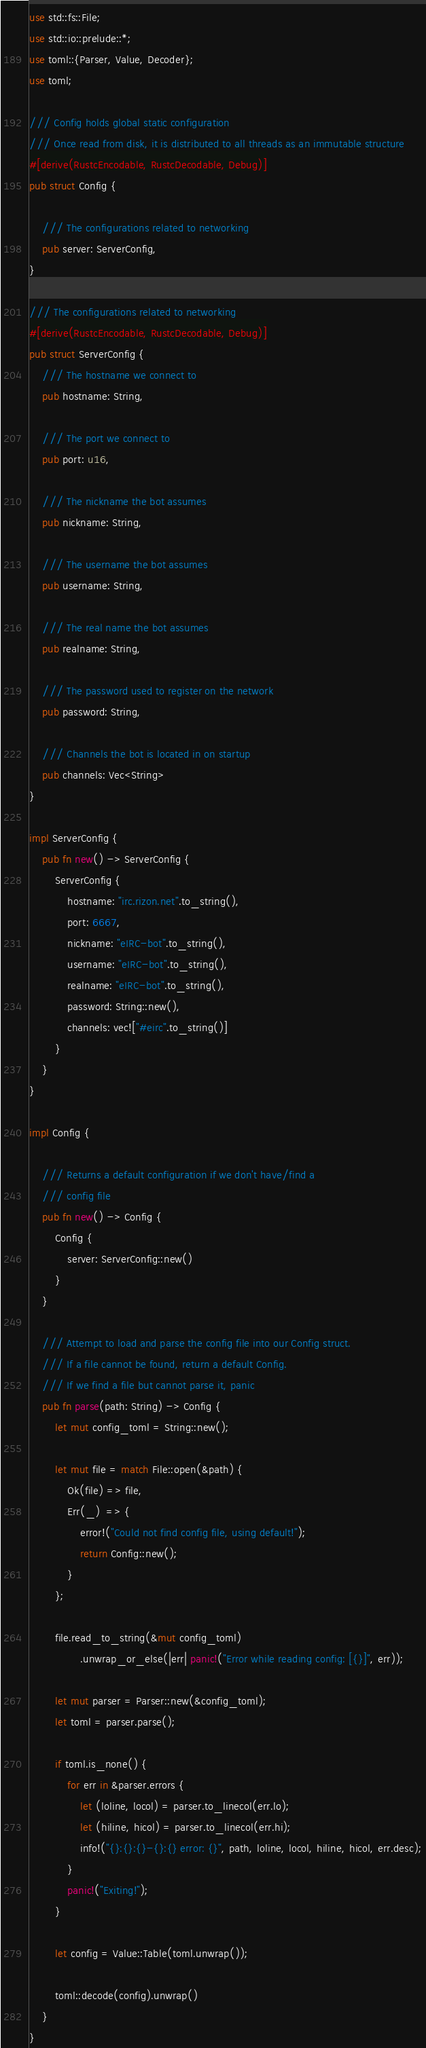<code> <loc_0><loc_0><loc_500><loc_500><_Rust_>use std::fs::File;
use std::io::prelude::*;
use toml::{Parser, Value, Decoder};
use toml;

/// Config holds global static configuration
/// Once read from disk, it is distributed to all threads as an immutable structure
#[derive(RustcEncodable, RustcDecodable, Debug)]
pub struct Config {

    /// The configurations related to networking
    pub server: ServerConfig,
}

/// The configurations related to networking
#[derive(RustcEncodable, RustcDecodable, Debug)]
pub struct ServerConfig {
    /// The hostname we connect to
    pub hostname: String,

    /// The port we connect to
    pub port: u16,

    /// The nickname the bot assumes
    pub nickname: String,

    /// The username the bot assumes
    pub username: String,

    /// The real name the bot assumes
    pub realname: String,

    /// The password used to register on the network
    pub password: String,

    /// Channels the bot is located in on startup
    pub channels: Vec<String>
}

impl ServerConfig {
    pub fn new() -> ServerConfig {
        ServerConfig {
            hostname: "irc.rizon.net".to_string(),
            port: 6667,
            nickname: "eIRC-bot".to_string(),
            username: "eIRC-bot".to_string(),
            realname: "eIRC-bot".to_string(),
            password: String::new(),
            channels: vec!["#eirc".to_string()]
        }
    }
}

impl Config {

    /// Returns a default configuration if we don't have/find a
    /// config file
    pub fn new() -> Config {
        Config {
            server: ServerConfig::new()
        }
    }

    /// Attempt to load and parse the config file into our Config struct.
    /// If a file cannot be found, return a default Config.
    /// If we find a file but cannot parse it, panic
    pub fn parse(path: String) -> Config {
        let mut config_toml = String::new();

        let mut file = match File::open(&path) {
            Ok(file) => file,
            Err(_)  => {
                error!("Could not find config file, using default!");
                return Config::new();
            }
        };

        file.read_to_string(&mut config_toml)
                .unwrap_or_else(|err| panic!("Error while reading config: [{}]", err));

        let mut parser = Parser::new(&config_toml);
        let toml = parser.parse();

        if toml.is_none() {
            for err in &parser.errors {
                let (loline, locol) = parser.to_linecol(err.lo);
                let (hiline, hicol) = parser.to_linecol(err.hi);
                info!("{}:{}:{}-{}:{} error: {}", path, loline, locol, hiline, hicol, err.desc);
            }
            panic!("Exiting!");
        }

        let config = Value::Table(toml.unwrap());

        toml::decode(config).unwrap()
    }
}

</code> 